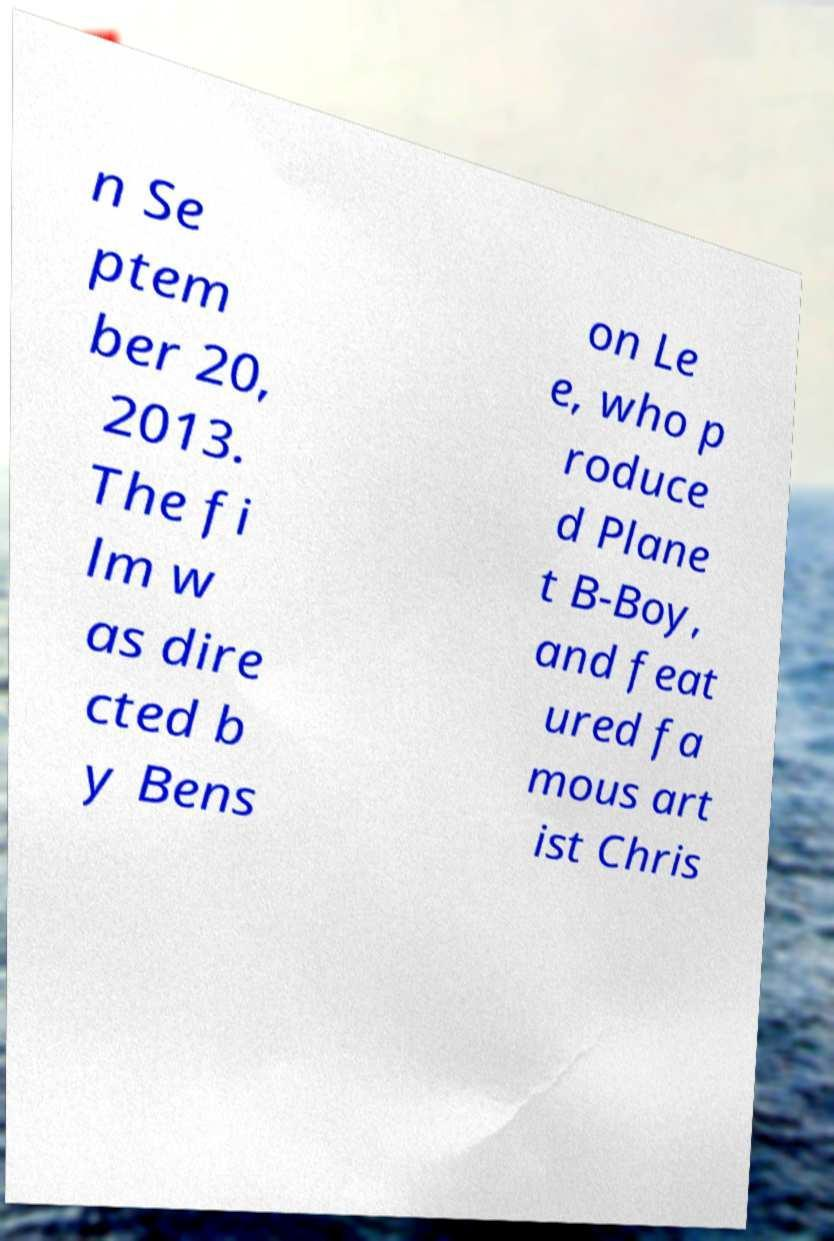Could you assist in decoding the text presented in this image and type it out clearly? n Se ptem ber 20, 2013. The fi lm w as dire cted b y Bens on Le e, who p roduce d Plane t B-Boy, and feat ured fa mous art ist Chris 